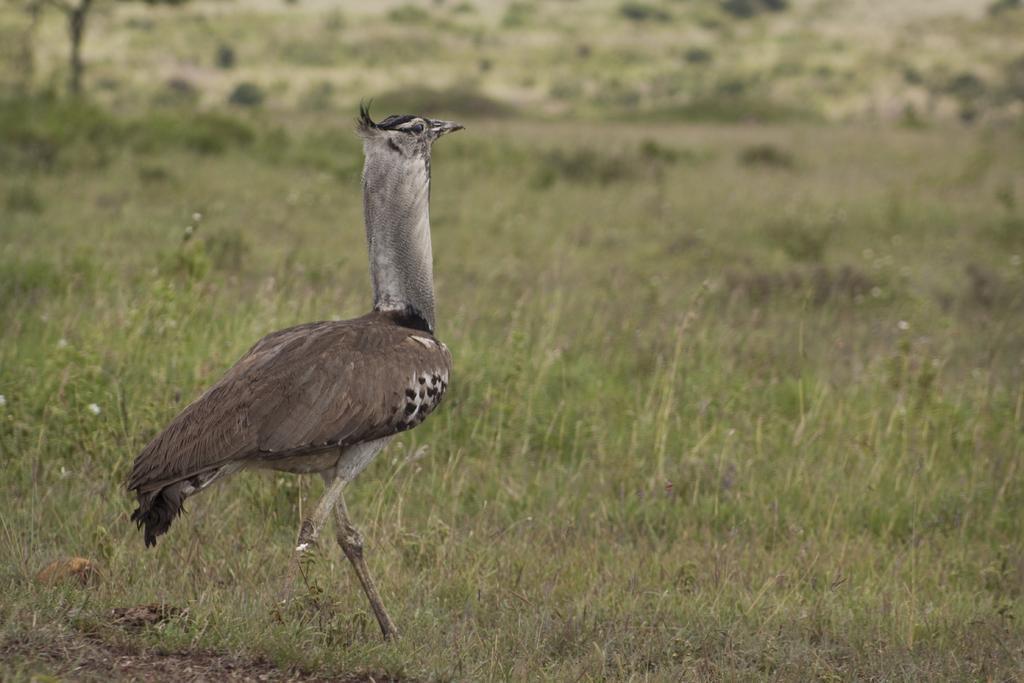In one or two sentences, can you explain what this image depicts? In the image we can see a bird, which is of brownish, white and black in color and we can see that it is standing on the grass. 